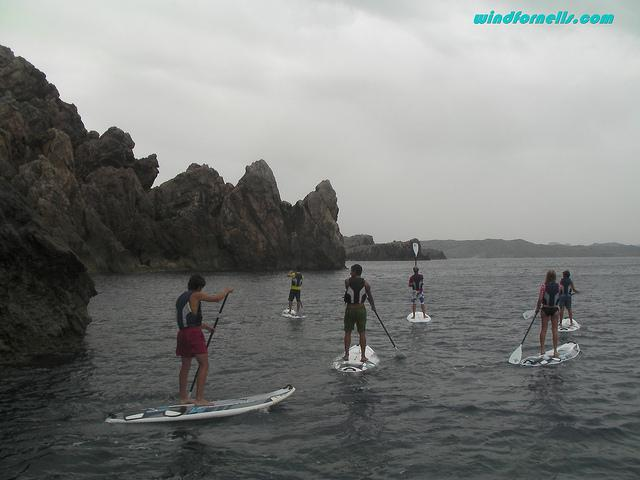What is required for this activity? Please explain your reasoning. water. The people are paddle boarding, not snowboarding, skating, or flying kites. 